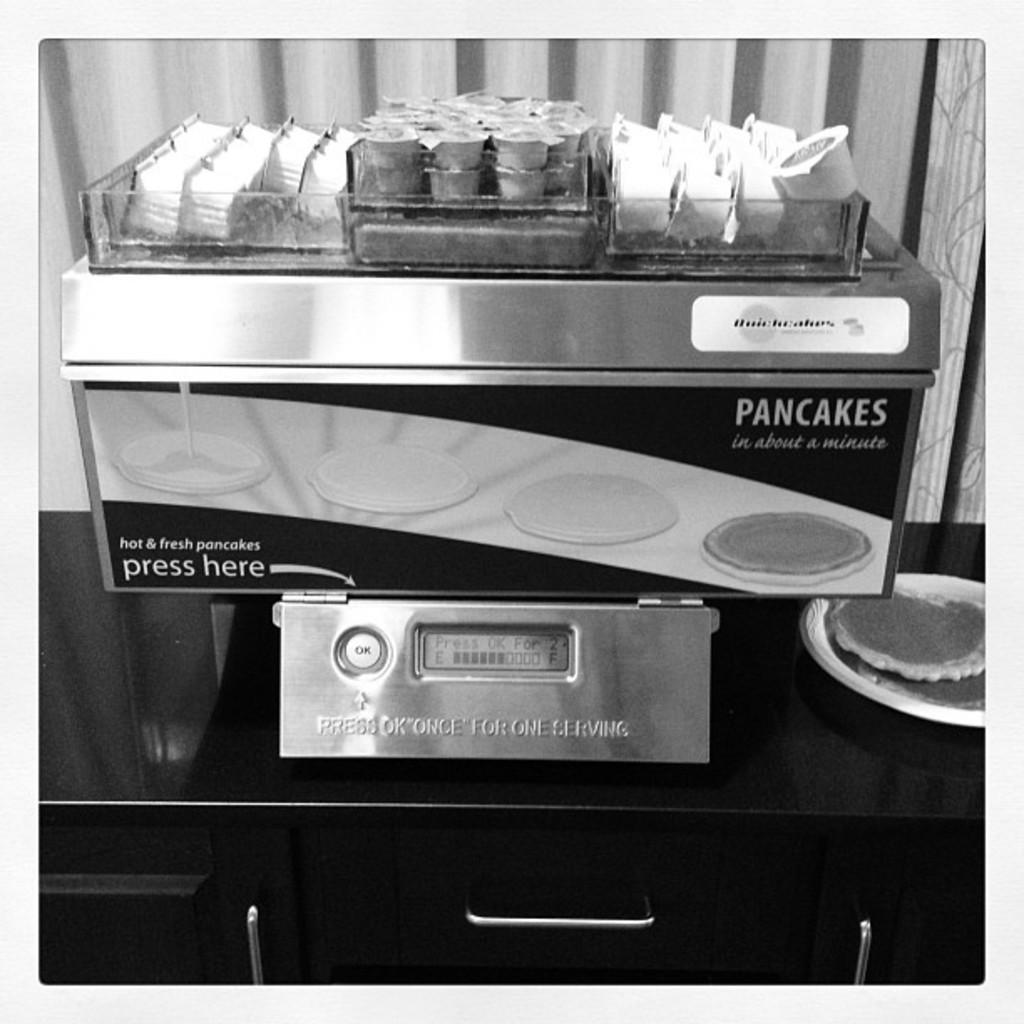<image>
Write a terse but informative summary of the picture. A machine promises pancakes in about a minute. 